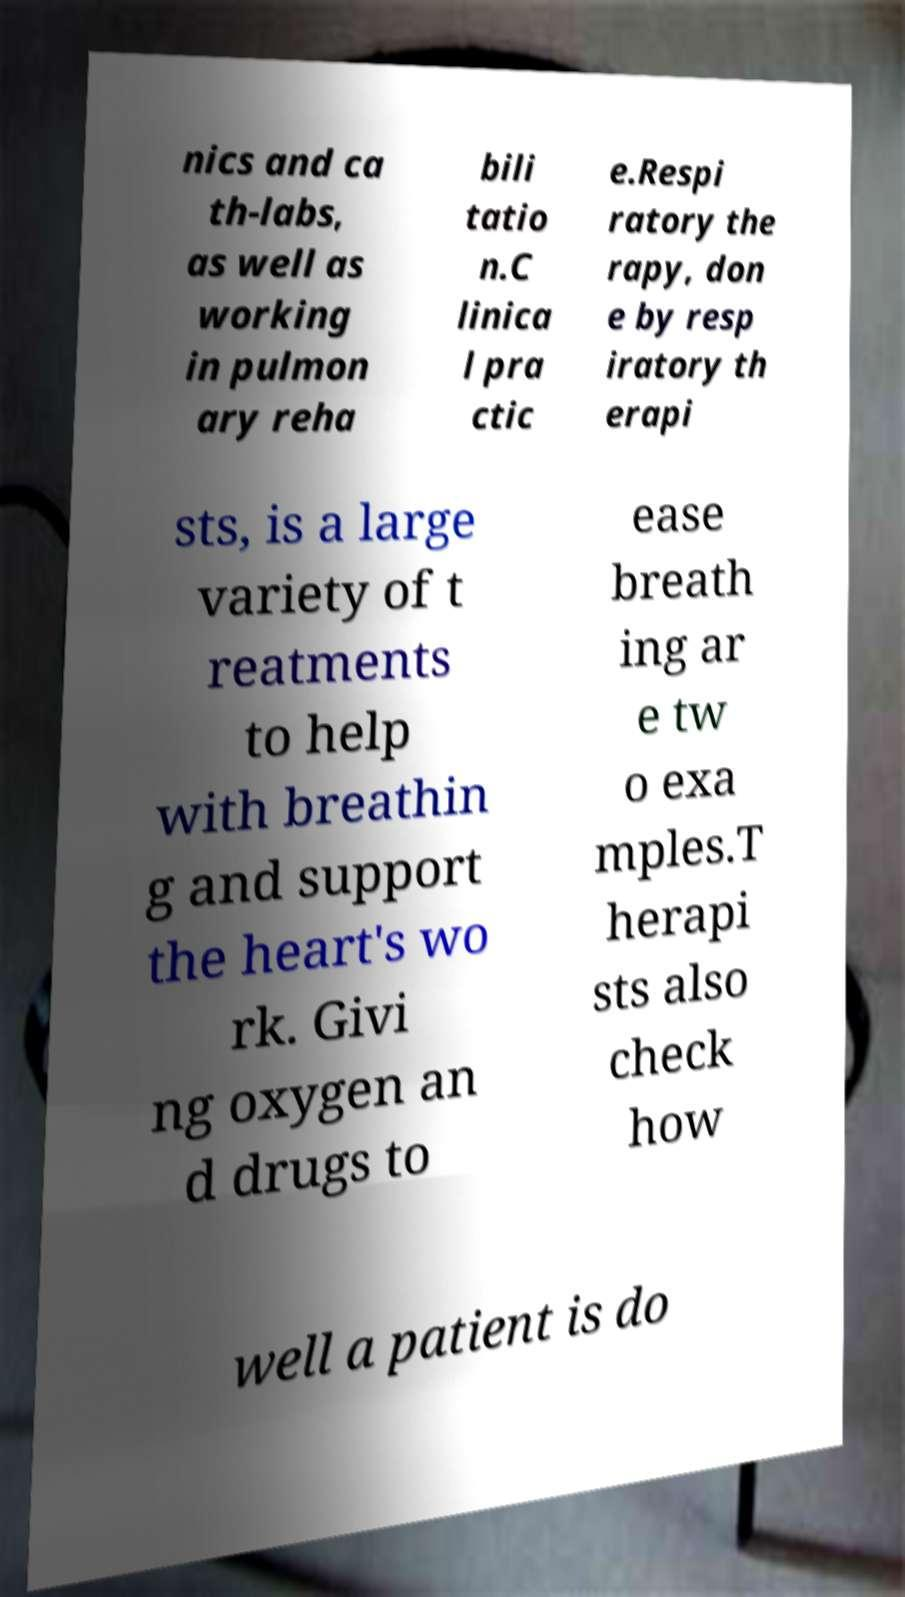What messages or text are displayed in this image? I need them in a readable, typed format. nics and ca th-labs, as well as working in pulmon ary reha bili tatio n.C linica l pra ctic e.Respi ratory the rapy, don e by resp iratory th erapi sts, is a large variety of t reatments to help with breathin g and support the heart's wo rk. Givi ng oxygen an d drugs to ease breath ing ar e tw o exa mples.T herapi sts also check how well a patient is do 